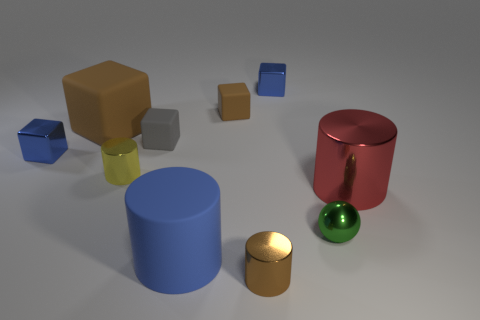Subtract all brown metallic cylinders. How many cylinders are left? 3 Subtract all brown cylinders. How many cylinders are left? 3 Subtract 2 cylinders. How many cylinders are left? 2 Subtract all red spheres. How many blue blocks are left? 2 Subtract all cylinders. How many objects are left? 6 Subtract all blue balls. Subtract all purple cylinders. How many balls are left? 1 Subtract all tiny brown cubes. Subtract all big objects. How many objects are left? 6 Add 2 small brown matte cubes. How many small brown matte cubes are left? 3 Add 5 large brown blocks. How many large brown blocks exist? 6 Subtract 0 yellow cubes. How many objects are left? 10 